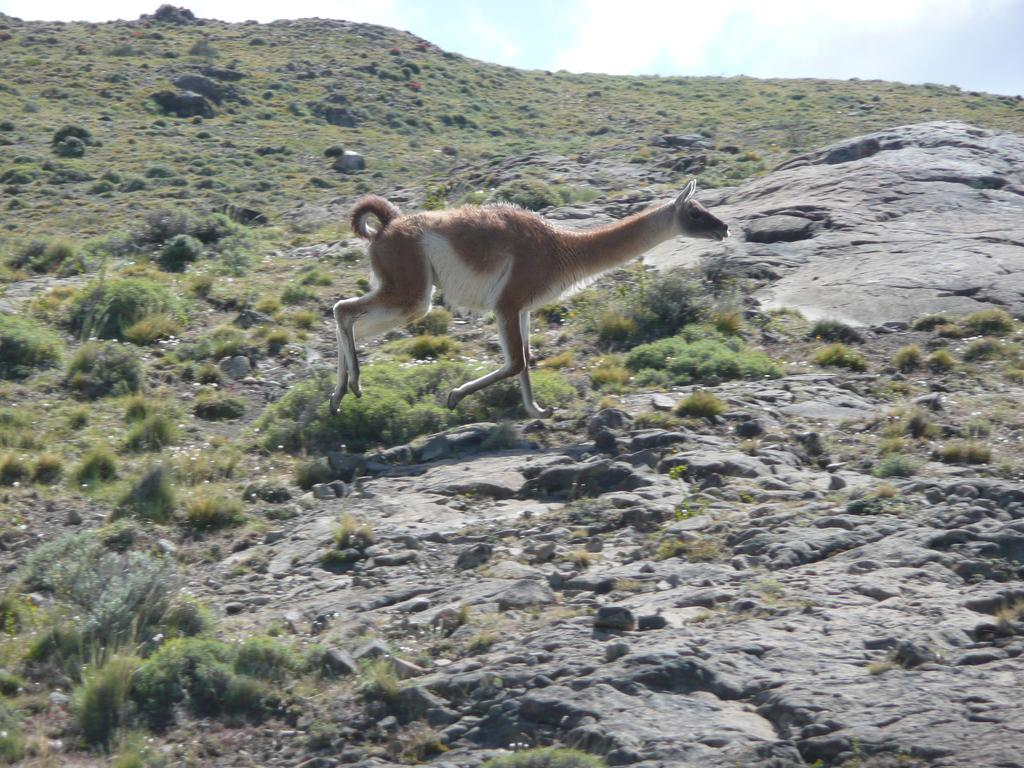What type of animal is in the image? There is a kangaroo in the image. What is the kangaroo standing on in the image? The kangaroo is on rocks in the image. What type of vegetation is present in the image? There are plants and grass in the image. What type of underwear is the kangaroo wearing in the image? There is no indication of the kangaroo wearing any underwear in the image. How long does it take for the kangaroo to jump in the image? The image does not show the kangaroo jumping, so it is not possible to determine how long it takes for the kangaroo to jump. What type of utensil is the kangaroo holding in the image? There is no utensil, such as a fork, present in the image. 